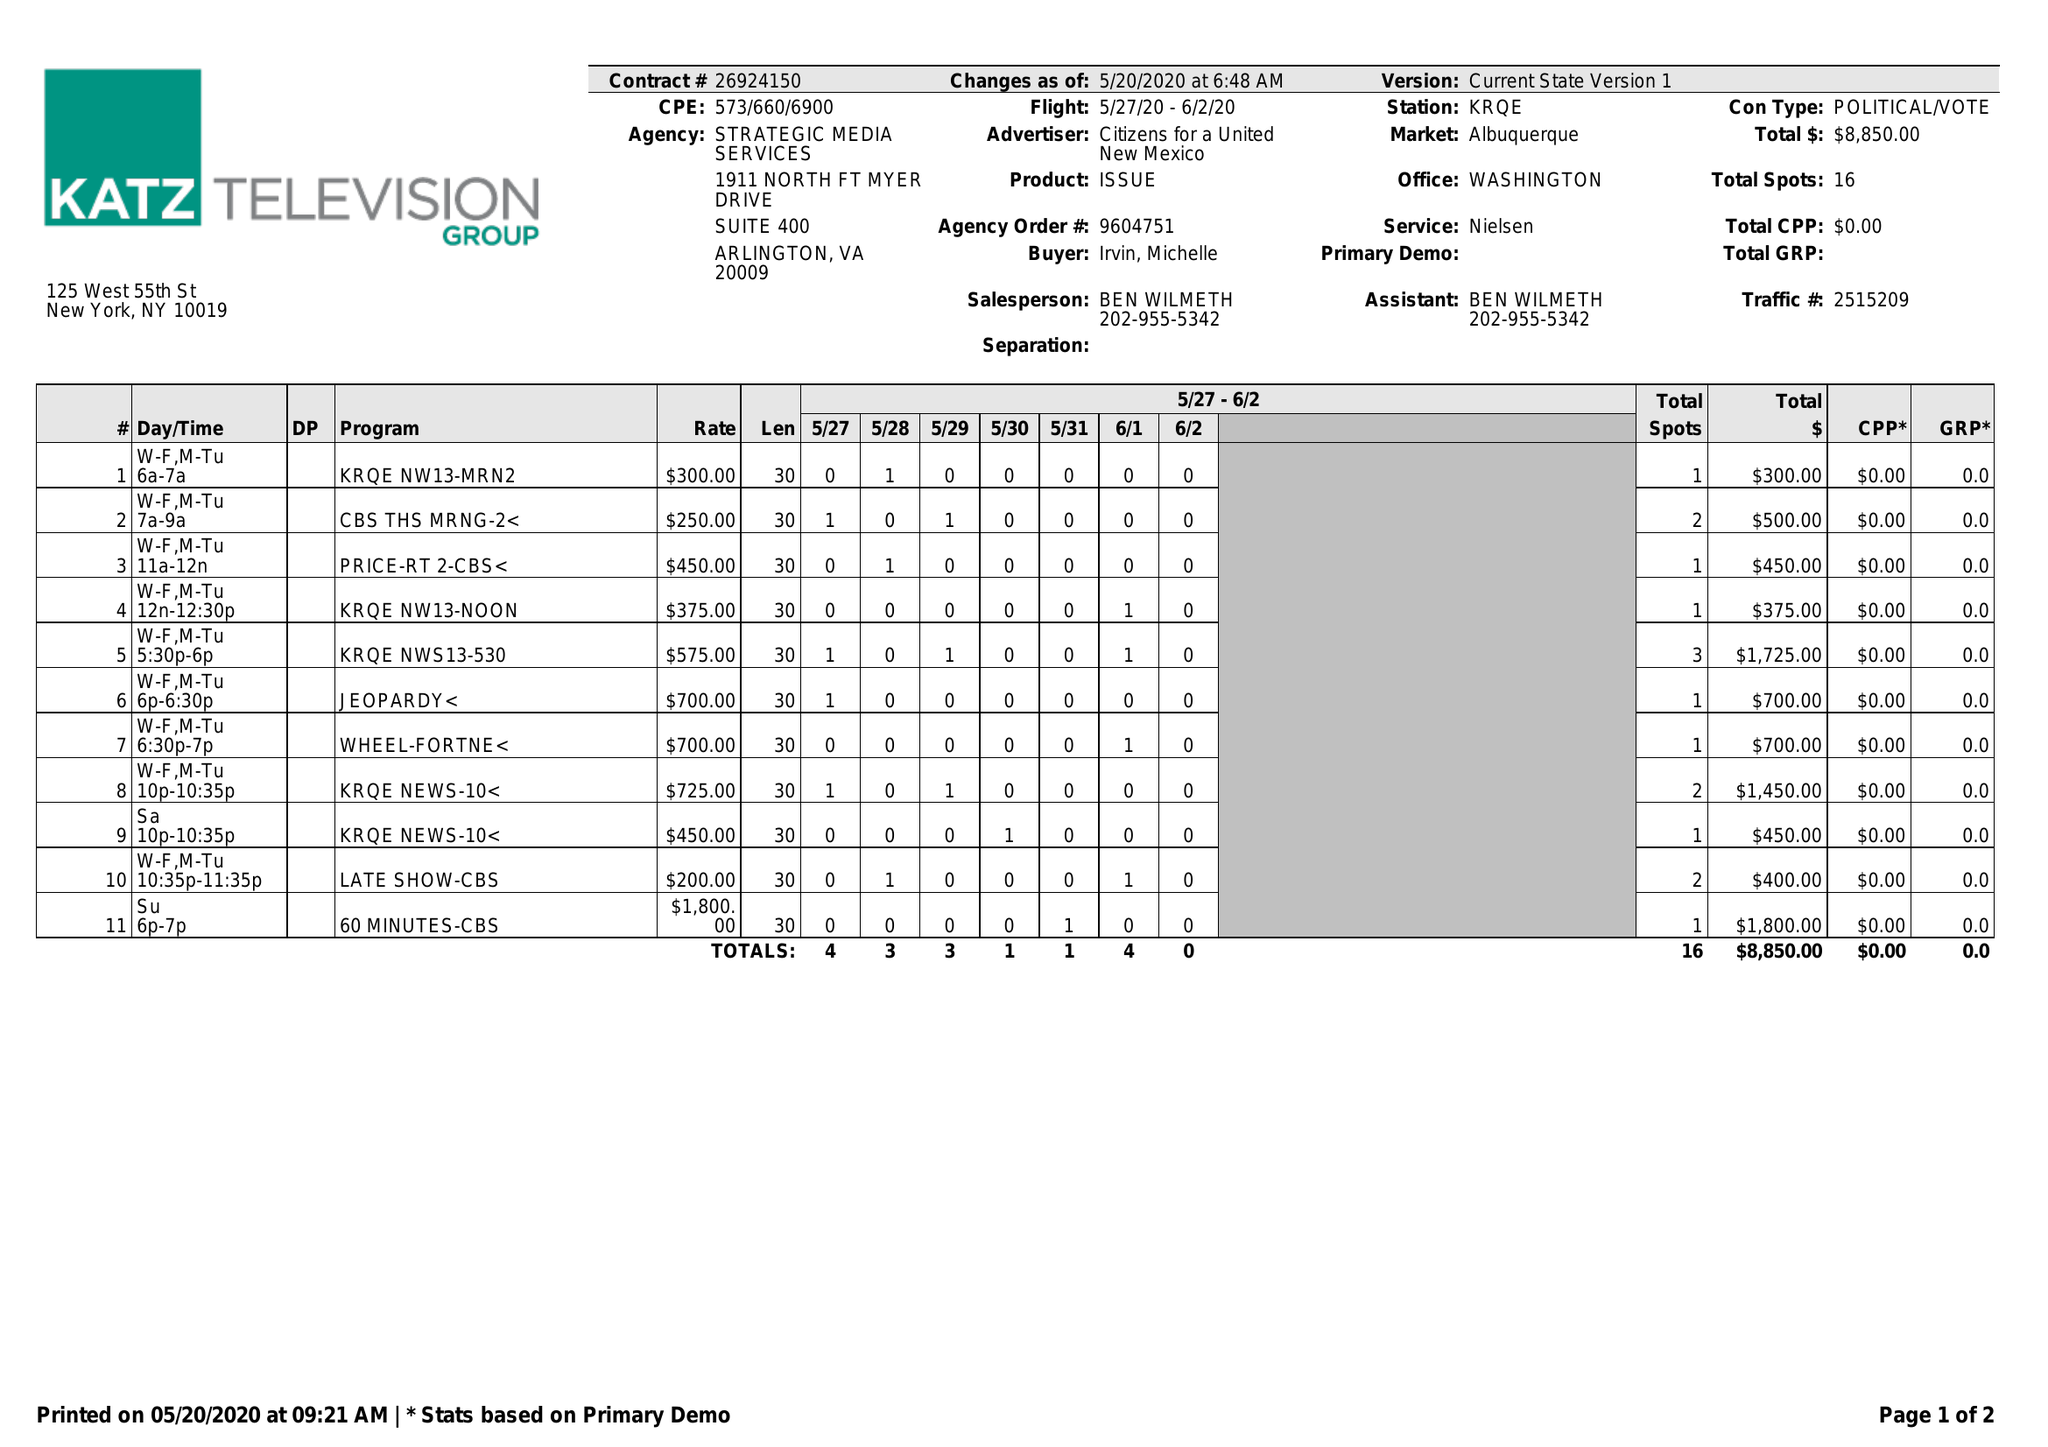What is the value for the contract_num?
Answer the question using a single word or phrase. 26924150 